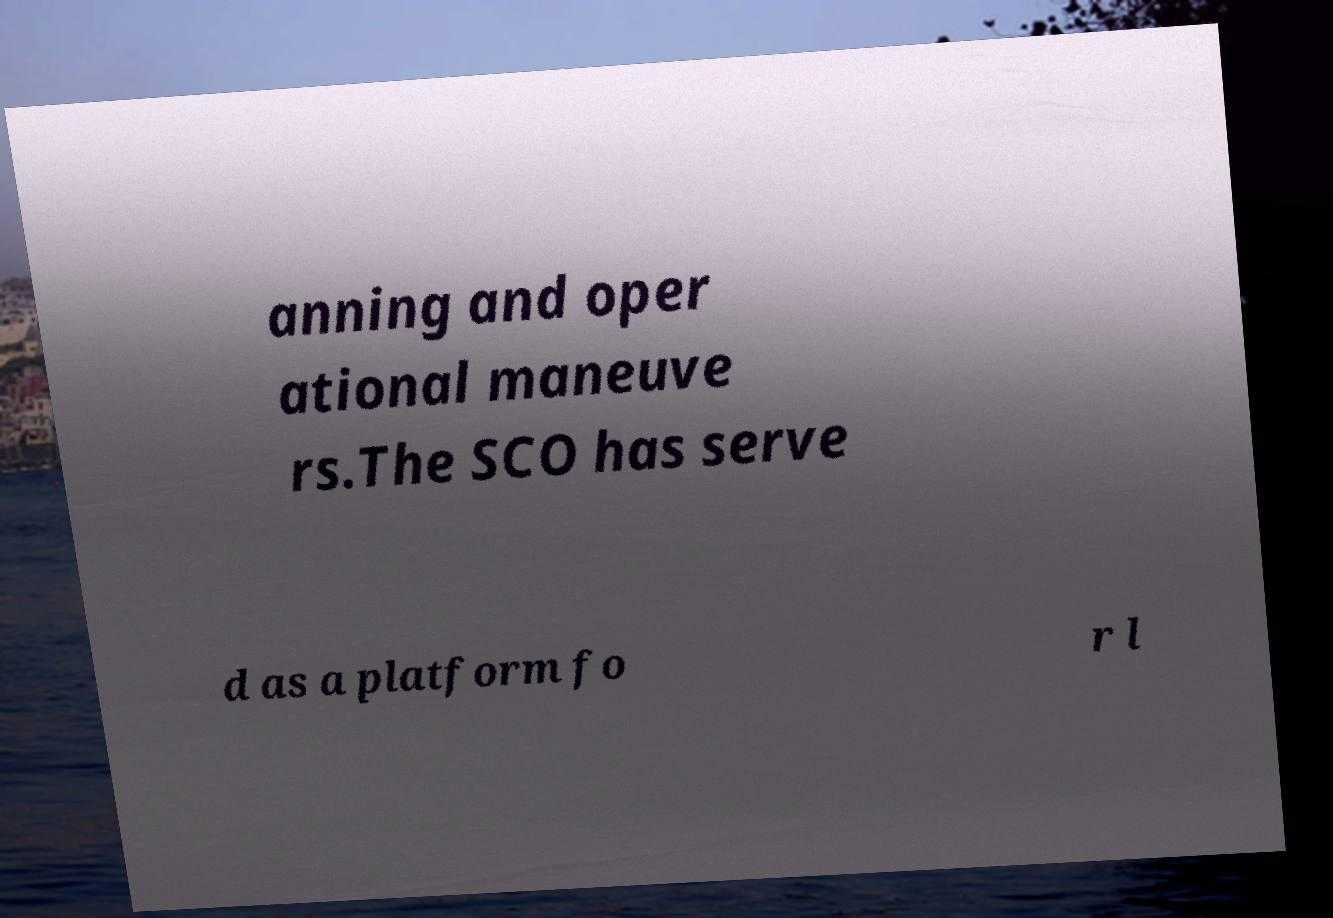There's text embedded in this image that I need extracted. Can you transcribe it verbatim? anning and oper ational maneuve rs.The SCO has serve d as a platform fo r l 